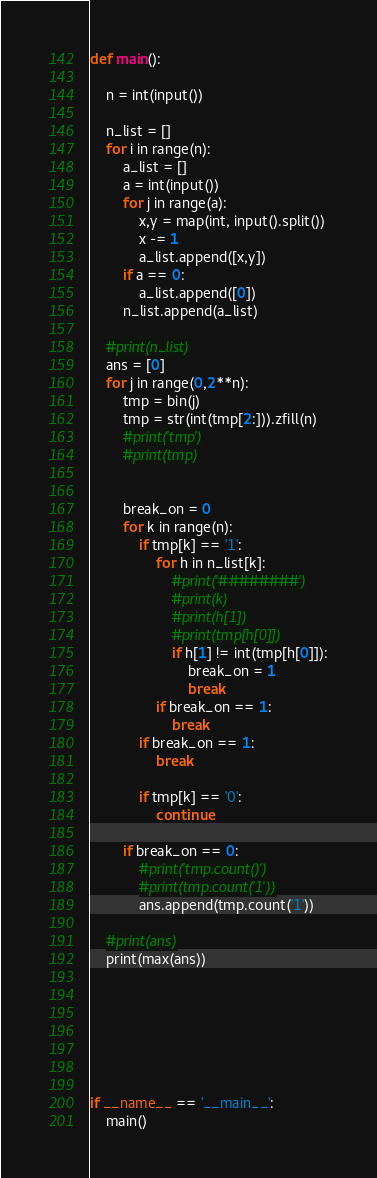Convert code to text. <code><loc_0><loc_0><loc_500><loc_500><_Python_>
def main():
    
    n = int(input())

    n_list = []
    for i in range(n):
        a_list = []
        a = int(input())
        for j in range(a):
            x,y = map(int, input().split())
            x -= 1
            a_list.append([x,y])
        if a == 0:
            a_list.append([0])
        n_list.append(a_list)

    #print(n_list)
    ans = [0]
    for j in range(0,2**n):
        tmp = bin(j)
        tmp = str(int(tmp[2:])).zfill(n)
        #print('tmp')
        #print(tmp)
        
        
        break_on = 0
        for k in range(n):
            if tmp[k] == '1':
                for h in n_list[k]:
                    #print('########')
                    #print(k)
                    #print(h[1])
                    #print(tmp[h[0]])
                    if h[1] != int(tmp[h[0]]):
                        break_on = 1
                        break
                if break_on == 1:
                    break
            if break_on == 1:
                break
            
            if tmp[k] == '0':
                continue
        
        if break_on == 0:
            #print('tmp.count()')
            #print(tmp.count('1'))
            ans.append(tmp.count('1'))
    
    #print(ans)
    print(max(ans))
    


            



if __name__ == '__main__':
    main()

</code> 